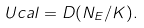<formula> <loc_0><loc_0><loc_500><loc_500>\ U c a l = D ( N _ { E } / K ) .</formula> 